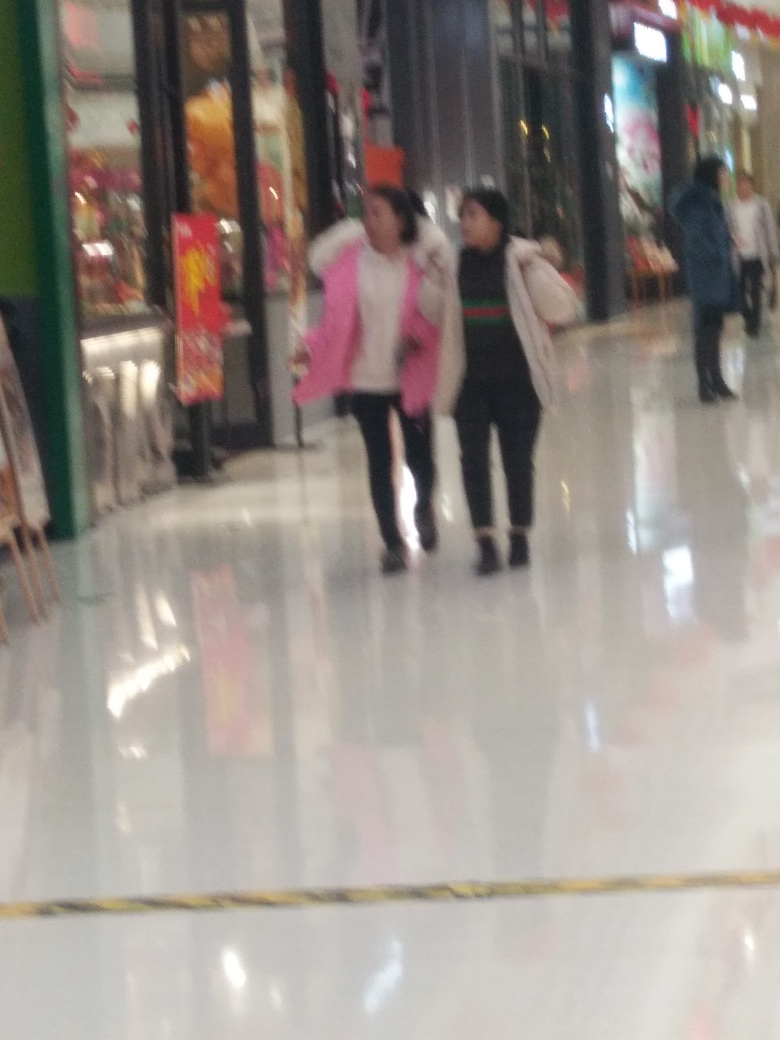Are there any quality issues with this image? The image appears to suffer from several quality issues such as blurriness, which affects the clarity of subjects and details, and improper exposure, leading to areas that seem overexposed. Additionally, the photo's composition and focus do not adhere to typical photography standards, such as the rule of thirds, which may detract from the viewer's experience. 